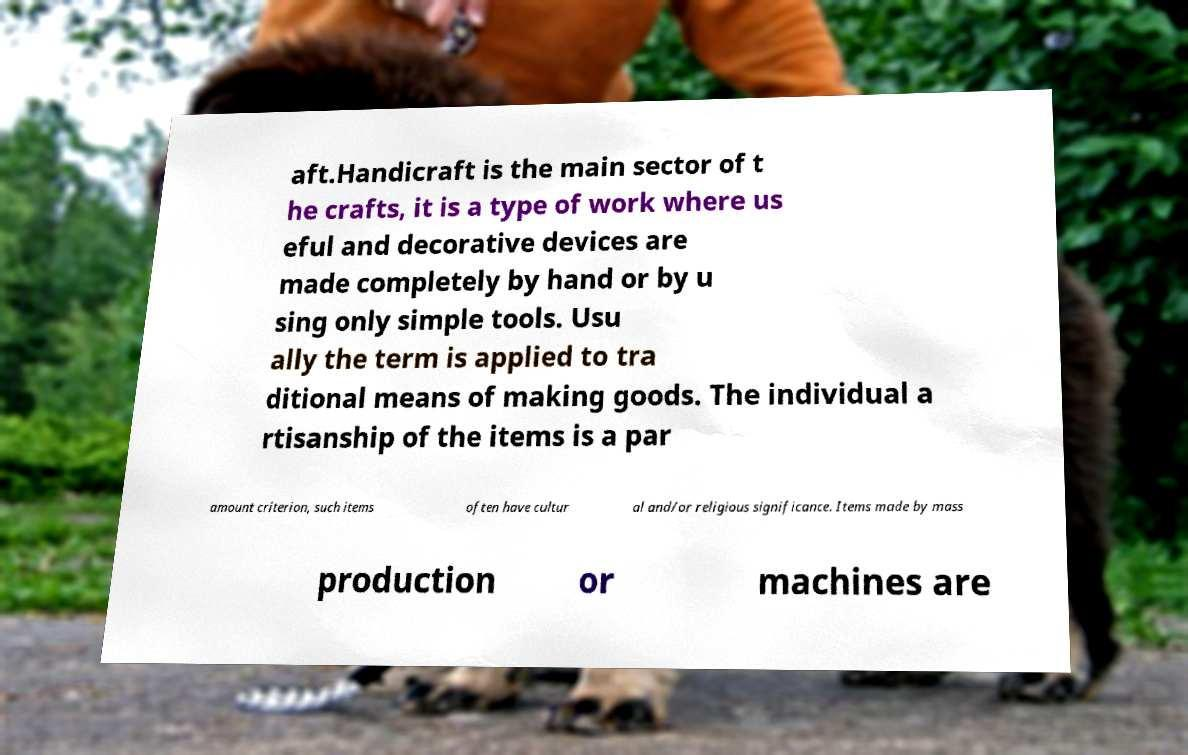What messages or text are displayed in this image? I need them in a readable, typed format. aft.Handicraft is the main sector of t he crafts, it is a type of work where us eful and decorative devices are made completely by hand or by u sing only simple tools. Usu ally the term is applied to tra ditional means of making goods. The individual a rtisanship of the items is a par amount criterion, such items often have cultur al and/or religious significance. Items made by mass production or machines are 